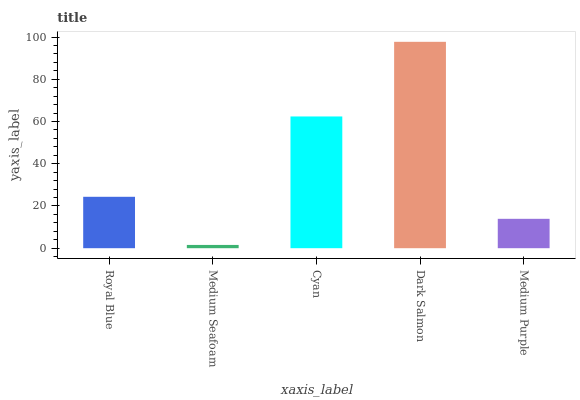Is Medium Seafoam the minimum?
Answer yes or no. Yes. Is Dark Salmon the maximum?
Answer yes or no. Yes. Is Cyan the minimum?
Answer yes or no. No. Is Cyan the maximum?
Answer yes or no. No. Is Cyan greater than Medium Seafoam?
Answer yes or no. Yes. Is Medium Seafoam less than Cyan?
Answer yes or no. Yes. Is Medium Seafoam greater than Cyan?
Answer yes or no. No. Is Cyan less than Medium Seafoam?
Answer yes or no. No. Is Royal Blue the high median?
Answer yes or no. Yes. Is Royal Blue the low median?
Answer yes or no. Yes. Is Dark Salmon the high median?
Answer yes or no. No. Is Medium Seafoam the low median?
Answer yes or no. No. 